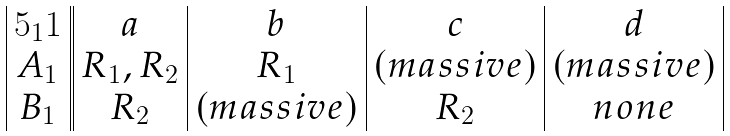<formula> <loc_0><loc_0><loc_500><loc_500>\begin{array} { | c | | c | c | c | c | } 5 _ { 1 } 1 & a & b & c & d \\ A _ { 1 } & R _ { 1 } , R _ { 2 } & R _ { 1 } & ( m a s s i v e ) & ( m a s s i v e ) \\ B _ { 1 } & R _ { 2 } & ( m a s s i v e ) & R _ { 2 } & n o n e \\ \end{array}</formula> 